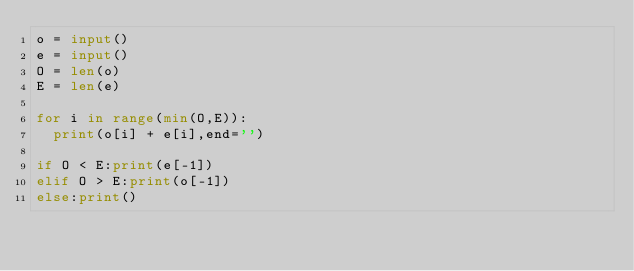<code> <loc_0><loc_0><loc_500><loc_500><_Python_>o = input()
e = input()
O = len(o)
E = len(e)

for i in range(min(O,E)):
	print(o[i] + e[i],end='')

if O < E:print(e[-1])
elif O > E:print(o[-1])
else:print()</code> 